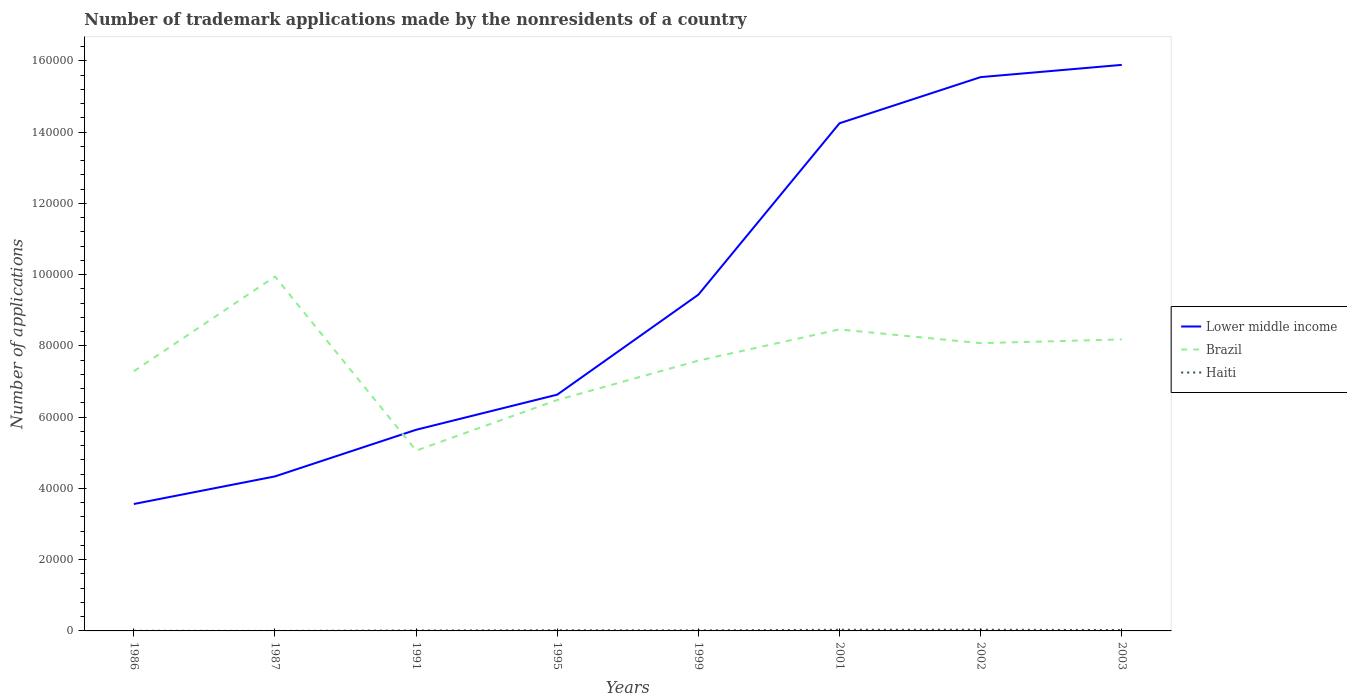Does the line corresponding to Haiti intersect with the line corresponding to Brazil?
Your answer should be compact. No. Across all years, what is the maximum number of trademark applications made by the nonresidents in Haiti?
Ensure brevity in your answer.  2. In which year was the number of trademark applications made by the nonresidents in Brazil maximum?
Your answer should be very brief. 1991. What is the difference between the highest and the second highest number of trademark applications made by the nonresidents in Brazil?
Keep it short and to the point. 4.89e+04. Is the number of trademark applications made by the nonresidents in Lower middle income strictly greater than the number of trademark applications made by the nonresidents in Brazil over the years?
Keep it short and to the point. No. How many years are there in the graph?
Give a very brief answer. 8. Are the values on the major ticks of Y-axis written in scientific E-notation?
Provide a short and direct response. No. Does the graph contain any zero values?
Your response must be concise. No. Where does the legend appear in the graph?
Keep it short and to the point. Center right. How are the legend labels stacked?
Keep it short and to the point. Vertical. What is the title of the graph?
Offer a terse response. Number of trademark applications made by the nonresidents of a country. Does "Least developed countries" appear as one of the legend labels in the graph?
Keep it short and to the point. No. What is the label or title of the Y-axis?
Ensure brevity in your answer.  Number of applications. What is the Number of applications in Lower middle income in 1986?
Provide a short and direct response. 3.56e+04. What is the Number of applications of Brazil in 1986?
Offer a very short reply. 7.29e+04. What is the Number of applications of Lower middle income in 1987?
Provide a short and direct response. 4.34e+04. What is the Number of applications of Brazil in 1987?
Offer a terse response. 9.95e+04. What is the Number of applications of Haiti in 1987?
Provide a short and direct response. 2. What is the Number of applications of Lower middle income in 1991?
Your answer should be very brief. 5.65e+04. What is the Number of applications of Brazil in 1991?
Keep it short and to the point. 5.06e+04. What is the Number of applications in Haiti in 1991?
Offer a terse response. 119. What is the Number of applications in Lower middle income in 1995?
Offer a terse response. 6.63e+04. What is the Number of applications in Brazil in 1995?
Your answer should be very brief. 6.48e+04. What is the Number of applications in Haiti in 1995?
Offer a very short reply. 183. What is the Number of applications in Lower middle income in 1999?
Keep it short and to the point. 9.44e+04. What is the Number of applications in Brazil in 1999?
Offer a very short reply. 7.59e+04. What is the Number of applications in Haiti in 1999?
Your response must be concise. 150. What is the Number of applications of Lower middle income in 2001?
Offer a very short reply. 1.43e+05. What is the Number of applications in Brazil in 2001?
Your answer should be very brief. 8.46e+04. What is the Number of applications in Haiti in 2001?
Make the answer very short. 323. What is the Number of applications in Lower middle income in 2002?
Provide a short and direct response. 1.55e+05. What is the Number of applications of Brazil in 2002?
Offer a very short reply. 8.08e+04. What is the Number of applications of Haiti in 2002?
Make the answer very short. 336. What is the Number of applications in Lower middle income in 2003?
Provide a succinct answer. 1.59e+05. What is the Number of applications of Brazil in 2003?
Make the answer very short. 8.18e+04. What is the Number of applications in Haiti in 2003?
Offer a terse response. 246. Across all years, what is the maximum Number of applications of Lower middle income?
Keep it short and to the point. 1.59e+05. Across all years, what is the maximum Number of applications of Brazil?
Keep it short and to the point. 9.95e+04. Across all years, what is the maximum Number of applications in Haiti?
Make the answer very short. 336. Across all years, what is the minimum Number of applications of Lower middle income?
Ensure brevity in your answer.  3.56e+04. Across all years, what is the minimum Number of applications of Brazil?
Offer a very short reply. 5.06e+04. What is the total Number of applications of Lower middle income in the graph?
Provide a short and direct response. 7.53e+05. What is the total Number of applications of Brazil in the graph?
Your answer should be very brief. 6.11e+05. What is the total Number of applications of Haiti in the graph?
Provide a short and direct response. 1395. What is the difference between the Number of applications in Lower middle income in 1986 and that in 1987?
Provide a short and direct response. -7748. What is the difference between the Number of applications in Brazil in 1986 and that in 1987?
Your response must be concise. -2.66e+04. What is the difference between the Number of applications in Lower middle income in 1986 and that in 1991?
Your answer should be very brief. -2.08e+04. What is the difference between the Number of applications in Brazil in 1986 and that in 1991?
Your answer should be very brief. 2.23e+04. What is the difference between the Number of applications of Haiti in 1986 and that in 1991?
Provide a short and direct response. -83. What is the difference between the Number of applications in Lower middle income in 1986 and that in 1995?
Offer a terse response. -3.07e+04. What is the difference between the Number of applications of Brazil in 1986 and that in 1995?
Offer a very short reply. 8082. What is the difference between the Number of applications of Haiti in 1986 and that in 1995?
Give a very brief answer. -147. What is the difference between the Number of applications of Lower middle income in 1986 and that in 1999?
Offer a terse response. -5.88e+04. What is the difference between the Number of applications of Brazil in 1986 and that in 1999?
Provide a short and direct response. -2978. What is the difference between the Number of applications of Haiti in 1986 and that in 1999?
Your answer should be very brief. -114. What is the difference between the Number of applications in Lower middle income in 1986 and that in 2001?
Your answer should be compact. -1.07e+05. What is the difference between the Number of applications of Brazil in 1986 and that in 2001?
Provide a short and direct response. -1.17e+04. What is the difference between the Number of applications of Haiti in 1986 and that in 2001?
Offer a very short reply. -287. What is the difference between the Number of applications of Lower middle income in 1986 and that in 2002?
Offer a terse response. -1.20e+05. What is the difference between the Number of applications in Brazil in 1986 and that in 2002?
Ensure brevity in your answer.  -7878. What is the difference between the Number of applications in Haiti in 1986 and that in 2002?
Provide a short and direct response. -300. What is the difference between the Number of applications in Lower middle income in 1986 and that in 2003?
Give a very brief answer. -1.23e+05. What is the difference between the Number of applications of Brazil in 1986 and that in 2003?
Ensure brevity in your answer.  -8928. What is the difference between the Number of applications in Haiti in 1986 and that in 2003?
Provide a succinct answer. -210. What is the difference between the Number of applications of Lower middle income in 1987 and that in 1991?
Provide a succinct answer. -1.31e+04. What is the difference between the Number of applications of Brazil in 1987 and that in 1991?
Offer a very short reply. 4.89e+04. What is the difference between the Number of applications in Haiti in 1987 and that in 1991?
Offer a terse response. -117. What is the difference between the Number of applications in Lower middle income in 1987 and that in 1995?
Make the answer very short. -2.30e+04. What is the difference between the Number of applications of Brazil in 1987 and that in 1995?
Make the answer very short. 3.47e+04. What is the difference between the Number of applications of Haiti in 1987 and that in 1995?
Keep it short and to the point. -181. What is the difference between the Number of applications in Lower middle income in 1987 and that in 1999?
Your answer should be very brief. -5.10e+04. What is the difference between the Number of applications of Brazil in 1987 and that in 1999?
Provide a succinct answer. 2.36e+04. What is the difference between the Number of applications of Haiti in 1987 and that in 1999?
Make the answer very short. -148. What is the difference between the Number of applications of Lower middle income in 1987 and that in 2001?
Make the answer very short. -9.91e+04. What is the difference between the Number of applications of Brazil in 1987 and that in 2001?
Your answer should be very brief. 1.48e+04. What is the difference between the Number of applications of Haiti in 1987 and that in 2001?
Make the answer very short. -321. What is the difference between the Number of applications of Lower middle income in 1987 and that in 2002?
Provide a short and direct response. -1.12e+05. What is the difference between the Number of applications of Brazil in 1987 and that in 2002?
Make the answer very short. 1.87e+04. What is the difference between the Number of applications of Haiti in 1987 and that in 2002?
Provide a succinct answer. -334. What is the difference between the Number of applications of Lower middle income in 1987 and that in 2003?
Your answer should be very brief. -1.16e+05. What is the difference between the Number of applications in Brazil in 1987 and that in 2003?
Ensure brevity in your answer.  1.77e+04. What is the difference between the Number of applications of Haiti in 1987 and that in 2003?
Offer a very short reply. -244. What is the difference between the Number of applications of Lower middle income in 1991 and that in 1995?
Your answer should be very brief. -9864. What is the difference between the Number of applications of Brazil in 1991 and that in 1995?
Give a very brief answer. -1.42e+04. What is the difference between the Number of applications in Haiti in 1991 and that in 1995?
Make the answer very short. -64. What is the difference between the Number of applications in Lower middle income in 1991 and that in 1999?
Provide a succinct answer. -3.79e+04. What is the difference between the Number of applications in Brazil in 1991 and that in 1999?
Your answer should be compact. -2.53e+04. What is the difference between the Number of applications of Haiti in 1991 and that in 1999?
Your answer should be compact. -31. What is the difference between the Number of applications of Lower middle income in 1991 and that in 2001?
Keep it short and to the point. -8.60e+04. What is the difference between the Number of applications of Brazil in 1991 and that in 2001?
Make the answer very short. -3.40e+04. What is the difference between the Number of applications in Haiti in 1991 and that in 2001?
Provide a short and direct response. -204. What is the difference between the Number of applications of Lower middle income in 1991 and that in 2002?
Offer a very short reply. -9.90e+04. What is the difference between the Number of applications in Brazil in 1991 and that in 2002?
Ensure brevity in your answer.  -3.02e+04. What is the difference between the Number of applications of Haiti in 1991 and that in 2002?
Your response must be concise. -217. What is the difference between the Number of applications of Lower middle income in 1991 and that in 2003?
Your response must be concise. -1.02e+05. What is the difference between the Number of applications of Brazil in 1991 and that in 2003?
Keep it short and to the point. -3.12e+04. What is the difference between the Number of applications in Haiti in 1991 and that in 2003?
Ensure brevity in your answer.  -127. What is the difference between the Number of applications in Lower middle income in 1995 and that in 1999?
Offer a terse response. -2.81e+04. What is the difference between the Number of applications of Brazil in 1995 and that in 1999?
Your response must be concise. -1.11e+04. What is the difference between the Number of applications in Lower middle income in 1995 and that in 2001?
Offer a very short reply. -7.62e+04. What is the difference between the Number of applications of Brazil in 1995 and that in 2001?
Your response must be concise. -1.98e+04. What is the difference between the Number of applications of Haiti in 1995 and that in 2001?
Provide a succinct answer. -140. What is the difference between the Number of applications in Lower middle income in 1995 and that in 2002?
Provide a short and direct response. -8.91e+04. What is the difference between the Number of applications of Brazil in 1995 and that in 2002?
Keep it short and to the point. -1.60e+04. What is the difference between the Number of applications of Haiti in 1995 and that in 2002?
Your answer should be compact. -153. What is the difference between the Number of applications of Lower middle income in 1995 and that in 2003?
Keep it short and to the point. -9.26e+04. What is the difference between the Number of applications of Brazil in 1995 and that in 2003?
Keep it short and to the point. -1.70e+04. What is the difference between the Number of applications in Haiti in 1995 and that in 2003?
Your response must be concise. -63. What is the difference between the Number of applications in Lower middle income in 1999 and that in 2001?
Your answer should be very brief. -4.81e+04. What is the difference between the Number of applications of Brazil in 1999 and that in 2001?
Provide a short and direct response. -8761. What is the difference between the Number of applications of Haiti in 1999 and that in 2001?
Your answer should be very brief. -173. What is the difference between the Number of applications in Lower middle income in 1999 and that in 2002?
Offer a terse response. -6.11e+04. What is the difference between the Number of applications of Brazil in 1999 and that in 2002?
Provide a short and direct response. -4900. What is the difference between the Number of applications of Haiti in 1999 and that in 2002?
Keep it short and to the point. -186. What is the difference between the Number of applications of Lower middle income in 1999 and that in 2003?
Make the answer very short. -6.45e+04. What is the difference between the Number of applications in Brazil in 1999 and that in 2003?
Provide a short and direct response. -5950. What is the difference between the Number of applications in Haiti in 1999 and that in 2003?
Ensure brevity in your answer.  -96. What is the difference between the Number of applications in Lower middle income in 2001 and that in 2002?
Your response must be concise. -1.30e+04. What is the difference between the Number of applications in Brazil in 2001 and that in 2002?
Give a very brief answer. 3861. What is the difference between the Number of applications in Lower middle income in 2001 and that in 2003?
Offer a very short reply. -1.64e+04. What is the difference between the Number of applications of Brazil in 2001 and that in 2003?
Your response must be concise. 2811. What is the difference between the Number of applications of Lower middle income in 2002 and that in 2003?
Offer a very short reply. -3437. What is the difference between the Number of applications of Brazil in 2002 and that in 2003?
Your answer should be compact. -1050. What is the difference between the Number of applications of Lower middle income in 1986 and the Number of applications of Brazil in 1987?
Offer a terse response. -6.39e+04. What is the difference between the Number of applications in Lower middle income in 1986 and the Number of applications in Haiti in 1987?
Offer a terse response. 3.56e+04. What is the difference between the Number of applications in Brazil in 1986 and the Number of applications in Haiti in 1987?
Offer a terse response. 7.29e+04. What is the difference between the Number of applications in Lower middle income in 1986 and the Number of applications in Brazil in 1991?
Your answer should be compact. -1.50e+04. What is the difference between the Number of applications in Lower middle income in 1986 and the Number of applications in Haiti in 1991?
Offer a very short reply. 3.55e+04. What is the difference between the Number of applications of Brazil in 1986 and the Number of applications of Haiti in 1991?
Provide a short and direct response. 7.28e+04. What is the difference between the Number of applications of Lower middle income in 1986 and the Number of applications of Brazil in 1995?
Your answer should be very brief. -2.92e+04. What is the difference between the Number of applications of Lower middle income in 1986 and the Number of applications of Haiti in 1995?
Provide a short and direct response. 3.54e+04. What is the difference between the Number of applications of Brazil in 1986 and the Number of applications of Haiti in 1995?
Make the answer very short. 7.27e+04. What is the difference between the Number of applications in Lower middle income in 1986 and the Number of applications in Brazil in 1999?
Give a very brief answer. -4.03e+04. What is the difference between the Number of applications of Lower middle income in 1986 and the Number of applications of Haiti in 1999?
Your answer should be very brief. 3.55e+04. What is the difference between the Number of applications of Brazil in 1986 and the Number of applications of Haiti in 1999?
Your response must be concise. 7.28e+04. What is the difference between the Number of applications in Lower middle income in 1986 and the Number of applications in Brazil in 2001?
Keep it short and to the point. -4.90e+04. What is the difference between the Number of applications of Lower middle income in 1986 and the Number of applications of Haiti in 2001?
Provide a succinct answer. 3.53e+04. What is the difference between the Number of applications in Brazil in 1986 and the Number of applications in Haiti in 2001?
Make the answer very short. 7.26e+04. What is the difference between the Number of applications of Lower middle income in 1986 and the Number of applications of Brazil in 2002?
Ensure brevity in your answer.  -4.52e+04. What is the difference between the Number of applications in Lower middle income in 1986 and the Number of applications in Haiti in 2002?
Provide a succinct answer. 3.53e+04. What is the difference between the Number of applications of Brazil in 1986 and the Number of applications of Haiti in 2002?
Offer a terse response. 7.26e+04. What is the difference between the Number of applications of Lower middle income in 1986 and the Number of applications of Brazil in 2003?
Offer a terse response. -4.62e+04. What is the difference between the Number of applications in Lower middle income in 1986 and the Number of applications in Haiti in 2003?
Provide a short and direct response. 3.54e+04. What is the difference between the Number of applications in Brazil in 1986 and the Number of applications in Haiti in 2003?
Make the answer very short. 7.27e+04. What is the difference between the Number of applications of Lower middle income in 1987 and the Number of applications of Brazil in 1991?
Give a very brief answer. -7242. What is the difference between the Number of applications of Lower middle income in 1987 and the Number of applications of Haiti in 1991?
Offer a terse response. 4.33e+04. What is the difference between the Number of applications in Brazil in 1987 and the Number of applications in Haiti in 1991?
Make the answer very short. 9.94e+04. What is the difference between the Number of applications in Lower middle income in 1987 and the Number of applications in Brazil in 1995?
Provide a succinct answer. -2.14e+04. What is the difference between the Number of applications of Lower middle income in 1987 and the Number of applications of Haiti in 1995?
Your response must be concise. 4.32e+04. What is the difference between the Number of applications in Brazil in 1987 and the Number of applications in Haiti in 1995?
Provide a short and direct response. 9.93e+04. What is the difference between the Number of applications of Lower middle income in 1987 and the Number of applications of Brazil in 1999?
Make the answer very short. -3.25e+04. What is the difference between the Number of applications of Lower middle income in 1987 and the Number of applications of Haiti in 1999?
Your answer should be very brief. 4.32e+04. What is the difference between the Number of applications of Brazil in 1987 and the Number of applications of Haiti in 1999?
Ensure brevity in your answer.  9.93e+04. What is the difference between the Number of applications of Lower middle income in 1987 and the Number of applications of Brazil in 2001?
Keep it short and to the point. -4.13e+04. What is the difference between the Number of applications in Lower middle income in 1987 and the Number of applications in Haiti in 2001?
Provide a short and direct response. 4.31e+04. What is the difference between the Number of applications in Brazil in 1987 and the Number of applications in Haiti in 2001?
Provide a succinct answer. 9.92e+04. What is the difference between the Number of applications in Lower middle income in 1987 and the Number of applications in Brazil in 2002?
Ensure brevity in your answer.  -3.74e+04. What is the difference between the Number of applications in Lower middle income in 1987 and the Number of applications in Haiti in 2002?
Make the answer very short. 4.30e+04. What is the difference between the Number of applications of Brazil in 1987 and the Number of applications of Haiti in 2002?
Provide a short and direct response. 9.91e+04. What is the difference between the Number of applications of Lower middle income in 1987 and the Number of applications of Brazil in 2003?
Your answer should be compact. -3.85e+04. What is the difference between the Number of applications in Lower middle income in 1987 and the Number of applications in Haiti in 2003?
Your response must be concise. 4.31e+04. What is the difference between the Number of applications of Brazil in 1987 and the Number of applications of Haiti in 2003?
Your answer should be compact. 9.92e+04. What is the difference between the Number of applications in Lower middle income in 1991 and the Number of applications in Brazil in 1995?
Your answer should be very brief. -8355. What is the difference between the Number of applications of Lower middle income in 1991 and the Number of applications of Haiti in 1995?
Offer a terse response. 5.63e+04. What is the difference between the Number of applications of Brazil in 1991 and the Number of applications of Haiti in 1995?
Your answer should be very brief. 5.04e+04. What is the difference between the Number of applications in Lower middle income in 1991 and the Number of applications in Brazil in 1999?
Your answer should be compact. -1.94e+04. What is the difference between the Number of applications of Lower middle income in 1991 and the Number of applications of Haiti in 1999?
Offer a terse response. 5.63e+04. What is the difference between the Number of applications in Brazil in 1991 and the Number of applications in Haiti in 1999?
Provide a short and direct response. 5.05e+04. What is the difference between the Number of applications in Lower middle income in 1991 and the Number of applications in Brazil in 2001?
Ensure brevity in your answer.  -2.82e+04. What is the difference between the Number of applications of Lower middle income in 1991 and the Number of applications of Haiti in 2001?
Offer a very short reply. 5.61e+04. What is the difference between the Number of applications in Brazil in 1991 and the Number of applications in Haiti in 2001?
Keep it short and to the point. 5.03e+04. What is the difference between the Number of applications in Lower middle income in 1991 and the Number of applications in Brazil in 2002?
Make the answer very short. -2.43e+04. What is the difference between the Number of applications in Lower middle income in 1991 and the Number of applications in Haiti in 2002?
Give a very brief answer. 5.61e+04. What is the difference between the Number of applications in Brazil in 1991 and the Number of applications in Haiti in 2002?
Ensure brevity in your answer.  5.03e+04. What is the difference between the Number of applications in Lower middle income in 1991 and the Number of applications in Brazil in 2003?
Your answer should be very brief. -2.54e+04. What is the difference between the Number of applications in Lower middle income in 1991 and the Number of applications in Haiti in 2003?
Your answer should be very brief. 5.62e+04. What is the difference between the Number of applications in Brazil in 1991 and the Number of applications in Haiti in 2003?
Provide a short and direct response. 5.04e+04. What is the difference between the Number of applications of Lower middle income in 1995 and the Number of applications of Brazil in 1999?
Offer a terse response. -9551. What is the difference between the Number of applications in Lower middle income in 1995 and the Number of applications in Haiti in 1999?
Your response must be concise. 6.62e+04. What is the difference between the Number of applications of Brazil in 1995 and the Number of applications of Haiti in 1999?
Your response must be concise. 6.47e+04. What is the difference between the Number of applications of Lower middle income in 1995 and the Number of applications of Brazil in 2001?
Offer a very short reply. -1.83e+04. What is the difference between the Number of applications of Lower middle income in 1995 and the Number of applications of Haiti in 2001?
Your response must be concise. 6.60e+04. What is the difference between the Number of applications of Brazil in 1995 and the Number of applications of Haiti in 2001?
Offer a very short reply. 6.45e+04. What is the difference between the Number of applications in Lower middle income in 1995 and the Number of applications in Brazil in 2002?
Offer a terse response. -1.45e+04. What is the difference between the Number of applications in Lower middle income in 1995 and the Number of applications in Haiti in 2002?
Your answer should be very brief. 6.60e+04. What is the difference between the Number of applications of Brazil in 1995 and the Number of applications of Haiti in 2002?
Your answer should be compact. 6.45e+04. What is the difference between the Number of applications in Lower middle income in 1995 and the Number of applications in Brazil in 2003?
Your response must be concise. -1.55e+04. What is the difference between the Number of applications in Lower middle income in 1995 and the Number of applications in Haiti in 2003?
Your answer should be very brief. 6.61e+04. What is the difference between the Number of applications in Brazil in 1995 and the Number of applications in Haiti in 2003?
Make the answer very short. 6.46e+04. What is the difference between the Number of applications in Lower middle income in 1999 and the Number of applications in Brazil in 2001?
Your answer should be compact. 9755. What is the difference between the Number of applications in Lower middle income in 1999 and the Number of applications in Haiti in 2001?
Your answer should be compact. 9.41e+04. What is the difference between the Number of applications of Brazil in 1999 and the Number of applications of Haiti in 2001?
Give a very brief answer. 7.56e+04. What is the difference between the Number of applications of Lower middle income in 1999 and the Number of applications of Brazil in 2002?
Make the answer very short. 1.36e+04. What is the difference between the Number of applications in Lower middle income in 1999 and the Number of applications in Haiti in 2002?
Give a very brief answer. 9.41e+04. What is the difference between the Number of applications in Brazil in 1999 and the Number of applications in Haiti in 2002?
Give a very brief answer. 7.55e+04. What is the difference between the Number of applications in Lower middle income in 1999 and the Number of applications in Brazil in 2003?
Your answer should be compact. 1.26e+04. What is the difference between the Number of applications of Lower middle income in 1999 and the Number of applications of Haiti in 2003?
Ensure brevity in your answer.  9.42e+04. What is the difference between the Number of applications in Brazil in 1999 and the Number of applications in Haiti in 2003?
Your response must be concise. 7.56e+04. What is the difference between the Number of applications of Lower middle income in 2001 and the Number of applications of Brazil in 2002?
Offer a terse response. 6.17e+04. What is the difference between the Number of applications in Lower middle income in 2001 and the Number of applications in Haiti in 2002?
Offer a very short reply. 1.42e+05. What is the difference between the Number of applications in Brazil in 2001 and the Number of applications in Haiti in 2002?
Offer a terse response. 8.43e+04. What is the difference between the Number of applications of Lower middle income in 2001 and the Number of applications of Brazil in 2003?
Provide a short and direct response. 6.07e+04. What is the difference between the Number of applications in Lower middle income in 2001 and the Number of applications in Haiti in 2003?
Give a very brief answer. 1.42e+05. What is the difference between the Number of applications of Brazil in 2001 and the Number of applications of Haiti in 2003?
Offer a terse response. 8.44e+04. What is the difference between the Number of applications in Lower middle income in 2002 and the Number of applications in Brazil in 2003?
Your answer should be compact. 7.36e+04. What is the difference between the Number of applications in Lower middle income in 2002 and the Number of applications in Haiti in 2003?
Offer a terse response. 1.55e+05. What is the difference between the Number of applications in Brazil in 2002 and the Number of applications in Haiti in 2003?
Give a very brief answer. 8.05e+04. What is the average Number of applications in Lower middle income per year?
Keep it short and to the point. 9.41e+04. What is the average Number of applications of Brazil per year?
Ensure brevity in your answer.  7.64e+04. What is the average Number of applications in Haiti per year?
Provide a short and direct response. 174.38. In the year 1986, what is the difference between the Number of applications of Lower middle income and Number of applications of Brazil?
Make the answer very short. -3.73e+04. In the year 1986, what is the difference between the Number of applications of Lower middle income and Number of applications of Haiti?
Ensure brevity in your answer.  3.56e+04. In the year 1986, what is the difference between the Number of applications in Brazil and Number of applications in Haiti?
Offer a very short reply. 7.29e+04. In the year 1987, what is the difference between the Number of applications of Lower middle income and Number of applications of Brazil?
Give a very brief answer. -5.61e+04. In the year 1987, what is the difference between the Number of applications in Lower middle income and Number of applications in Haiti?
Offer a very short reply. 4.34e+04. In the year 1987, what is the difference between the Number of applications of Brazil and Number of applications of Haiti?
Keep it short and to the point. 9.95e+04. In the year 1991, what is the difference between the Number of applications in Lower middle income and Number of applications in Brazil?
Provide a short and direct response. 5846. In the year 1991, what is the difference between the Number of applications of Lower middle income and Number of applications of Haiti?
Ensure brevity in your answer.  5.63e+04. In the year 1991, what is the difference between the Number of applications in Brazil and Number of applications in Haiti?
Provide a succinct answer. 5.05e+04. In the year 1995, what is the difference between the Number of applications in Lower middle income and Number of applications in Brazil?
Ensure brevity in your answer.  1509. In the year 1995, what is the difference between the Number of applications of Lower middle income and Number of applications of Haiti?
Your answer should be compact. 6.61e+04. In the year 1995, what is the difference between the Number of applications in Brazil and Number of applications in Haiti?
Your answer should be compact. 6.46e+04. In the year 1999, what is the difference between the Number of applications in Lower middle income and Number of applications in Brazil?
Offer a terse response. 1.85e+04. In the year 1999, what is the difference between the Number of applications in Lower middle income and Number of applications in Haiti?
Your response must be concise. 9.42e+04. In the year 1999, what is the difference between the Number of applications of Brazil and Number of applications of Haiti?
Your answer should be very brief. 7.57e+04. In the year 2001, what is the difference between the Number of applications of Lower middle income and Number of applications of Brazil?
Ensure brevity in your answer.  5.79e+04. In the year 2001, what is the difference between the Number of applications in Lower middle income and Number of applications in Haiti?
Your answer should be compact. 1.42e+05. In the year 2001, what is the difference between the Number of applications in Brazil and Number of applications in Haiti?
Your response must be concise. 8.43e+04. In the year 2002, what is the difference between the Number of applications in Lower middle income and Number of applications in Brazil?
Your answer should be very brief. 7.47e+04. In the year 2002, what is the difference between the Number of applications in Lower middle income and Number of applications in Haiti?
Make the answer very short. 1.55e+05. In the year 2002, what is the difference between the Number of applications of Brazil and Number of applications of Haiti?
Keep it short and to the point. 8.04e+04. In the year 2003, what is the difference between the Number of applications of Lower middle income and Number of applications of Brazil?
Offer a terse response. 7.71e+04. In the year 2003, what is the difference between the Number of applications of Lower middle income and Number of applications of Haiti?
Provide a short and direct response. 1.59e+05. In the year 2003, what is the difference between the Number of applications in Brazil and Number of applications in Haiti?
Offer a very short reply. 8.16e+04. What is the ratio of the Number of applications in Lower middle income in 1986 to that in 1987?
Your answer should be very brief. 0.82. What is the ratio of the Number of applications of Brazil in 1986 to that in 1987?
Your response must be concise. 0.73. What is the ratio of the Number of applications in Lower middle income in 1986 to that in 1991?
Provide a succinct answer. 0.63. What is the ratio of the Number of applications of Brazil in 1986 to that in 1991?
Offer a very short reply. 1.44. What is the ratio of the Number of applications in Haiti in 1986 to that in 1991?
Provide a succinct answer. 0.3. What is the ratio of the Number of applications of Lower middle income in 1986 to that in 1995?
Make the answer very short. 0.54. What is the ratio of the Number of applications of Brazil in 1986 to that in 1995?
Your answer should be very brief. 1.12. What is the ratio of the Number of applications in Haiti in 1986 to that in 1995?
Provide a succinct answer. 0.2. What is the ratio of the Number of applications in Lower middle income in 1986 to that in 1999?
Keep it short and to the point. 0.38. What is the ratio of the Number of applications of Brazil in 1986 to that in 1999?
Your answer should be very brief. 0.96. What is the ratio of the Number of applications in Haiti in 1986 to that in 1999?
Your answer should be very brief. 0.24. What is the ratio of the Number of applications of Brazil in 1986 to that in 2001?
Offer a terse response. 0.86. What is the ratio of the Number of applications of Haiti in 1986 to that in 2001?
Your answer should be compact. 0.11. What is the ratio of the Number of applications in Lower middle income in 1986 to that in 2002?
Provide a short and direct response. 0.23. What is the ratio of the Number of applications of Brazil in 1986 to that in 2002?
Your answer should be compact. 0.9. What is the ratio of the Number of applications in Haiti in 1986 to that in 2002?
Ensure brevity in your answer.  0.11. What is the ratio of the Number of applications in Lower middle income in 1986 to that in 2003?
Your answer should be very brief. 0.22. What is the ratio of the Number of applications in Brazil in 1986 to that in 2003?
Your answer should be compact. 0.89. What is the ratio of the Number of applications in Haiti in 1986 to that in 2003?
Provide a succinct answer. 0.15. What is the ratio of the Number of applications in Lower middle income in 1987 to that in 1991?
Ensure brevity in your answer.  0.77. What is the ratio of the Number of applications of Brazil in 1987 to that in 1991?
Your answer should be very brief. 1.97. What is the ratio of the Number of applications in Haiti in 1987 to that in 1991?
Provide a short and direct response. 0.02. What is the ratio of the Number of applications in Lower middle income in 1987 to that in 1995?
Give a very brief answer. 0.65. What is the ratio of the Number of applications of Brazil in 1987 to that in 1995?
Your answer should be very brief. 1.53. What is the ratio of the Number of applications in Haiti in 1987 to that in 1995?
Provide a short and direct response. 0.01. What is the ratio of the Number of applications of Lower middle income in 1987 to that in 1999?
Offer a terse response. 0.46. What is the ratio of the Number of applications in Brazil in 1987 to that in 1999?
Your answer should be compact. 1.31. What is the ratio of the Number of applications in Haiti in 1987 to that in 1999?
Offer a terse response. 0.01. What is the ratio of the Number of applications in Lower middle income in 1987 to that in 2001?
Ensure brevity in your answer.  0.3. What is the ratio of the Number of applications in Brazil in 1987 to that in 2001?
Give a very brief answer. 1.18. What is the ratio of the Number of applications of Haiti in 1987 to that in 2001?
Offer a very short reply. 0.01. What is the ratio of the Number of applications in Lower middle income in 1987 to that in 2002?
Your response must be concise. 0.28. What is the ratio of the Number of applications of Brazil in 1987 to that in 2002?
Keep it short and to the point. 1.23. What is the ratio of the Number of applications in Haiti in 1987 to that in 2002?
Provide a succinct answer. 0.01. What is the ratio of the Number of applications in Lower middle income in 1987 to that in 2003?
Offer a very short reply. 0.27. What is the ratio of the Number of applications of Brazil in 1987 to that in 2003?
Keep it short and to the point. 1.22. What is the ratio of the Number of applications of Haiti in 1987 to that in 2003?
Your response must be concise. 0.01. What is the ratio of the Number of applications in Lower middle income in 1991 to that in 1995?
Provide a succinct answer. 0.85. What is the ratio of the Number of applications in Brazil in 1991 to that in 1995?
Offer a terse response. 0.78. What is the ratio of the Number of applications in Haiti in 1991 to that in 1995?
Provide a succinct answer. 0.65. What is the ratio of the Number of applications of Lower middle income in 1991 to that in 1999?
Your answer should be compact. 0.6. What is the ratio of the Number of applications in Brazil in 1991 to that in 1999?
Give a very brief answer. 0.67. What is the ratio of the Number of applications in Haiti in 1991 to that in 1999?
Offer a very short reply. 0.79. What is the ratio of the Number of applications in Lower middle income in 1991 to that in 2001?
Your response must be concise. 0.4. What is the ratio of the Number of applications of Brazil in 1991 to that in 2001?
Your answer should be very brief. 0.6. What is the ratio of the Number of applications of Haiti in 1991 to that in 2001?
Your answer should be compact. 0.37. What is the ratio of the Number of applications of Lower middle income in 1991 to that in 2002?
Provide a succinct answer. 0.36. What is the ratio of the Number of applications of Brazil in 1991 to that in 2002?
Your answer should be compact. 0.63. What is the ratio of the Number of applications in Haiti in 1991 to that in 2002?
Keep it short and to the point. 0.35. What is the ratio of the Number of applications of Lower middle income in 1991 to that in 2003?
Your answer should be compact. 0.36. What is the ratio of the Number of applications in Brazil in 1991 to that in 2003?
Offer a very short reply. 0.62. What is the ratio of the Number of applications of Haiti in 1991 to that in 2003?
Your answer should be compact. 0.48. What is the ratio of the Number of applications of Lower middle income in 1995 to that in 1999?
Offer a terse response. 0.7. What is the ratio of the Number of applications of Brazil in 1995 to that in 1999?
Offer a very short reply. 0.85. What is the ratio of the Number of applications of Haiti in 1995 to that in 1999?
Offer a very short reply. 1.22. What is the ratio of the Number of applications in Lower middle income in 1995 to that in 2001?
Provide a succinct answer. 0.47. What is the ratio of the Number of applications of Brazil in 1995 to that in 2001?
Your response must be concise. 0.77. What is the ratio of the Number of applications in Haiti in 1995 to that in 2001?
Ensure brevity in your answer.  0.57. What is the ratio of the Number of applications of Lower middle income in 1995 to that in 2002?
Your response must be concise. 0.43. What is the ratio of the Number of applications of Brazil in 1995 to that in 2002?
Ensure brevity in your answer.  0.8. What is the ratio of the Number of applications of Haiti in 1995 to that in 2002?
Your answer should be compact. 0.54. What is the ratio of the Number of applications in Lower middle income in 1995 to that in 2003?
Provide a succinct answer. 0.42. What is the ratio of the Number of applications in Brazil in 1995 to that in 2003?
Offer a very short reply. 0.79. What is the ratio of the Number of applications in Haiti in 1995 to that in 2003?
Your response must be concise. 0.74. What is the ratio of the Number of applications in Lower middle income in 1999 to that in 2001?
Make the answer very short. 0.66. What is the ratio of the Number of applications in Brazil in 1999 to that in 2001?
Your answer should be compact. 0.9. What is the ratio of the Number of applications of Haiti in 1999 to that in 2001?
Keep it short and to the point. 0.46. What is the ratio of the Number of applications of Lower middle income in 1999 to that in 2002?
Make the answer very short. 0.61. What is the ratio of the Number of applications of Brazil in 1999 to that in 2002?
Provide a short and direct response. 0.94. What is the ratio of the Number of applications in Haiti in 1999 to that in 2002?
Your answer should be very brief. 0.45. What is the ratio of the Number of applications in Lower middle income in 1999 to that in 2003?
Make the answer very short. 0.59. What is the ratio of the Number of applications in Brazil in 1999 to that in 2003?
Give a very brief answer. 0.93. What is the ratio of the Number of applications in Haiti in 1999 to that in 2003?
Your answer should be compact. 0.61. What is the ratio of the Number of applications of Lower middle income in 2001 to that in 2002?
Provide a short and direct response. 0.92. What is the ratio of the Number of applications of Brazil in 2001 to that in 2002?
Keep it short and to the point. 1.05. What is the ratio of the Number of applications of Haiti in 2001 to that in 2002?
Offer a terse response. 0.96. What is the ratio of the Number of applications in Lower middle income in 2001 to that in 2003?
Provide a short and direct response. 0.9. What is the ratio of the Number of applications in Brazil in 2001 to that in 2003?
Keep it short and to the point. 1.03. What is the ratio of the Number of applications of Haiti in 2001 to that in 2003?
Offer a very short reply. 1.31. What is the ratio of the Number of applications of Lower middle income in 2002 to that in 2003?
Keep it short and to the point. 0.98. What is the ratio of the Number of applications of Brazil in 2002 to that in 2003?
Ensure brevity in your answer.  0.99. What is the ratio of the Number of applications of Haiti in 2002 to that in 2003?
Your answer should be compact. 1.37. What is the difference between the highest and the second highest Number of applications of Lower middle income?
Give a very brief answer. 3437. What is the difference between the highest and the second highest Number of applications in Brazil?
Ensure brevity in your answer.  1.48e+04. What is the difference between the highest and the second highest Number of applications of Haiti?
Offer a very short reply. 13. What is the difference between the highest and the lowest Number of applications in Lower middle income?
Keep it short and to the point. 1.23e+05. What is the difference between the highest and the lowest Number of applications in Brazil?
Provide a short and direct response. 4.89e+04. What is the difference between the highest and the lowest Number of applications of Haiti?
Ensure brevity in your answer.  334. 